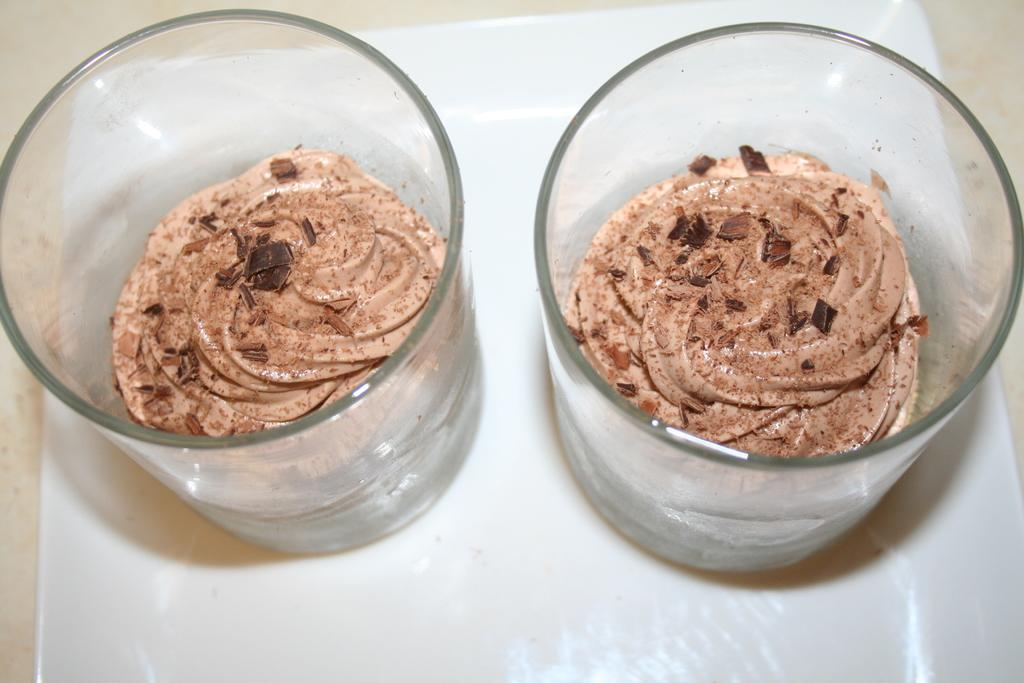What type of desserts are in the image? The desserts in the image are in glasses. How are the desserts arranged or organized? The desserts are kept in a tray. Where might the tray be located? The tray may be on a table. What type of setting is the image likely taken in? The image is likely taken in a room. What type of apparel is worn by the desserts in the image? There is no apparel worn by the desserts in the image, as they are inanimate objects. 